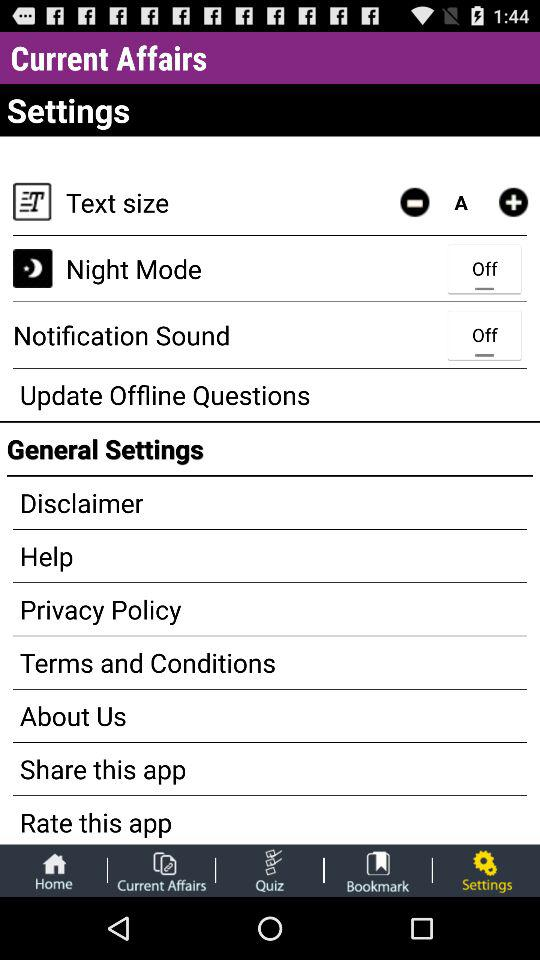What is the setting for night mode? The setting for night mode is "off". 